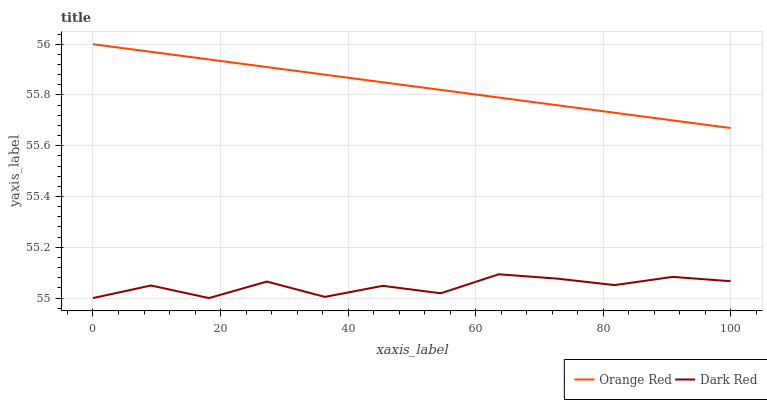Does Dark Red have the minimum area under the curve?
Answer yes or no. Yes. Does Orange Red have the maximum area under the curve?
Answer yes or no. Yes. Does Orange Red have the minimum area under the curve?
Answer yes or no. No. Is Orange Red the smoothest?
Answer yes or no. Yes. Is Dark Red the roughest?
Answer yes or no. Yes. Is Orange Red the roughest?
Answer yes or no. No. Does Dark Red have the lowest value?
Answer yes or no. Yes. Does Orange Red have the lowest value?
Answer yes or no. No. Does Orange Red have the highest value?
Answer yes or no. Yes. Is Dark Red less than Orange Red?
Answer yes or no. Yes. Is Orange Red greater than Dark Red?
Answer yes or no. Yes. Does Dark Red intersect Orange Red?
Answer yes or no. No. 